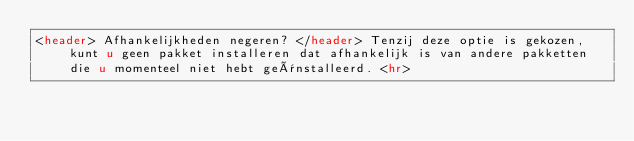<code> <loc_0><loc_0><loc_500><loc_500><_HTML_><header> Afhankelijkheden negeren? </header> Tenzij deze optie is gekozen, kunt u geen pakket installeren dat afhankelijk is van andere pakketten die u momenteel niet hebt geïnstalleerd. <hr></code> 